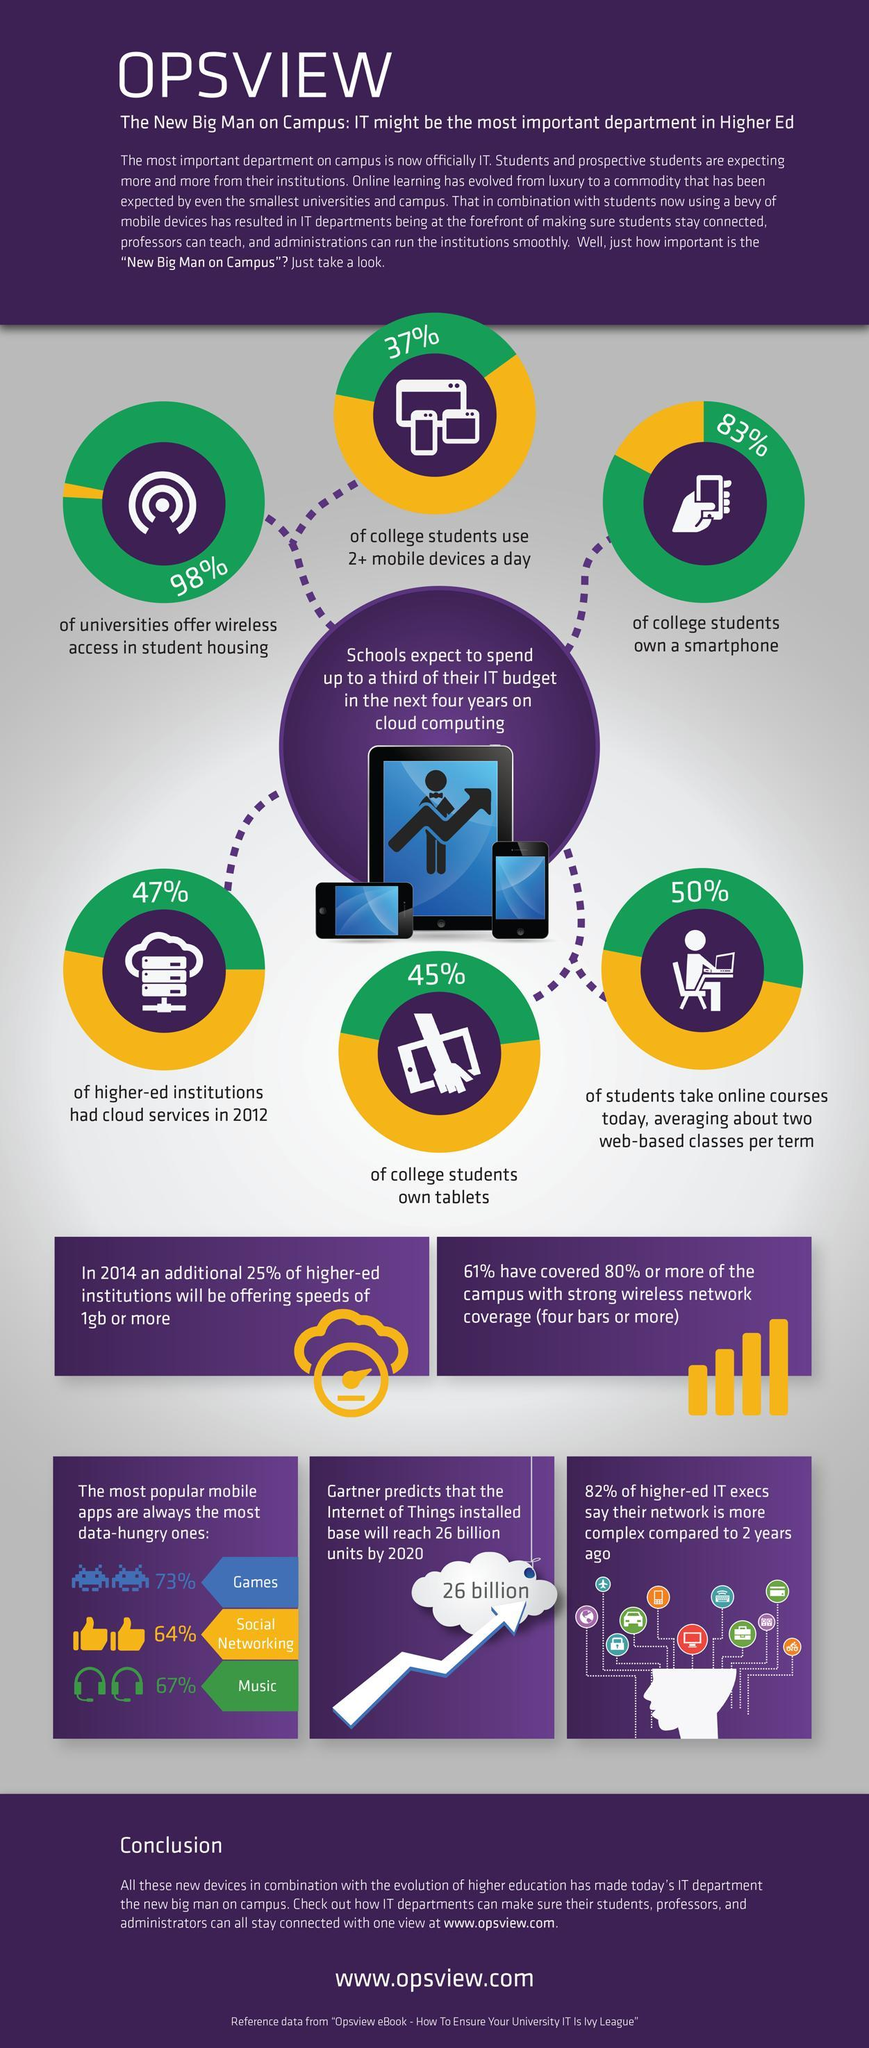What percentage of universities do not provide wi-fi in student hostels?
Answer the question with a short phrase. 2% What percentage of college students do not own a smart phone? 17% What percentage of students do not use more than 2 mobile devices a day? 63% What is the average in percentage of users using games, social media, and music apps? 68% What percentage of students do not own tabs? 55% What percentage of institutions did not have cloud services in 2012? 53% 